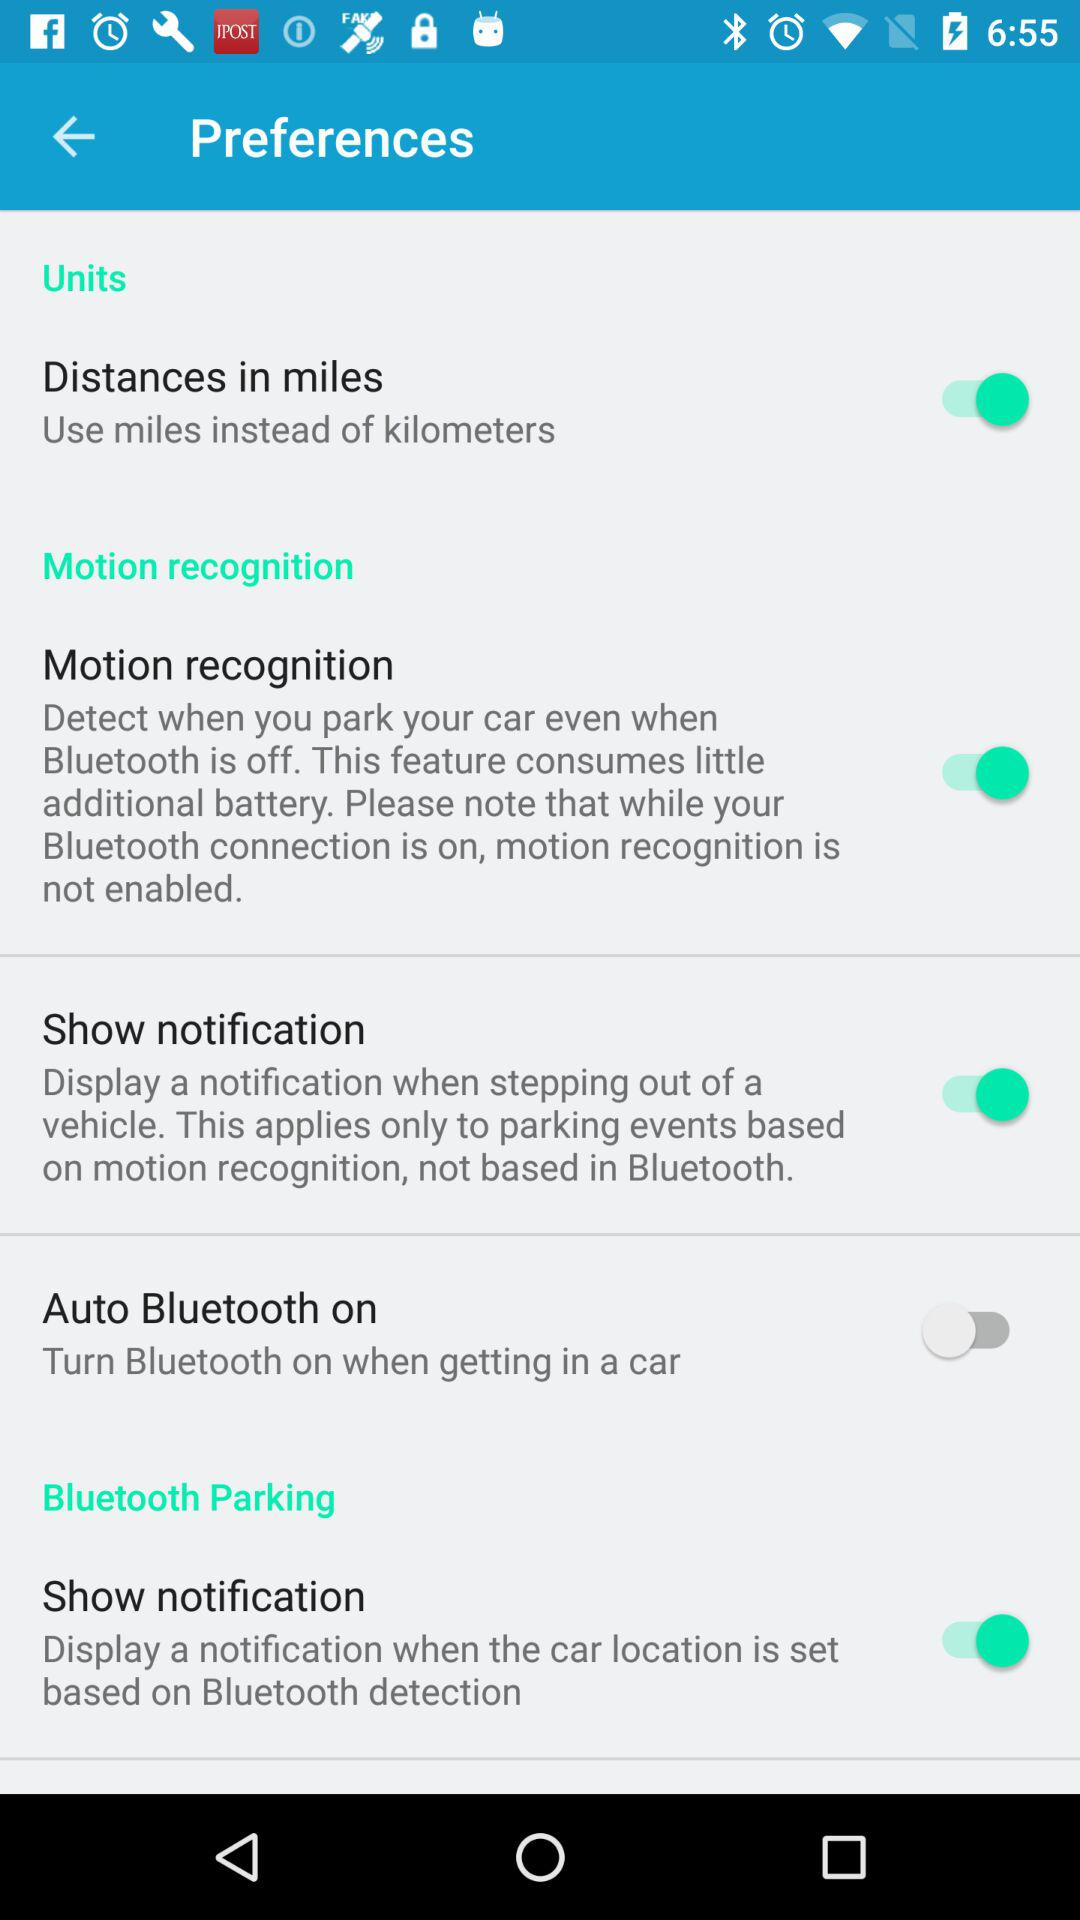What is the status of "Auto Bluetooth on"? The status is "off". 